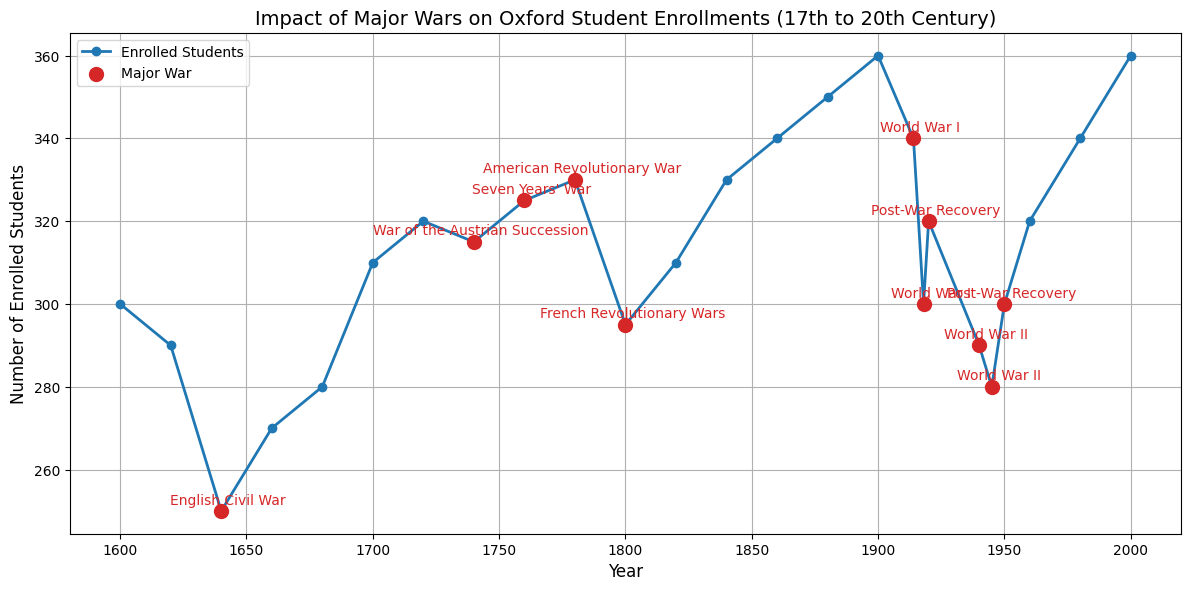What is the lowest student enrollment during a major war? To determine the lowest student enrollment during a major war, look for the points marked in red. The lowest value among these points is 280 students during World War II in 1945.
Answer: 280 Which major war resulted in the highest decrease in student enrollments? Check the differences in student enrollments before and during/after each major war. The most significant difference is observed during World War II, where enrollments dropped from 340 in 1914 to 300 in 1918, a decrease of 40 students.
Answer: World War II In which periods do we see a recovery in student enrollments after a major war, and by how much does the enrollment increase in these periods? After World War I, student enrollments increase from 300 in 1918 to 320 in 1920, an increase of 20 students. After World War II, enrollments rise from 280 in 1945 to 300 in 1950, an increase of 20 students.
Answer: Post-World War I: 20, Post-World War II: 20 What is the average student enrollment for the decade 1900-1910? Look at the enrollment numbers for the years 1900 (360). The average is calculated from (360) / 1 = 360.
Answer: 360 How does the student enrollment in 1740 (War of the Austrian Succession) compare to that in 1760 (Seven Years' War)? Compare the enrollment numbers for 1740 and 1760. In 1740, the enrollment was 315, while in 1760, it was 325. The enrollment in 1760 is higher by 10 students.
Answer: 1760 Which major war saw the least impact on student enrollment, considering the immediate pre- and post-war figures? Compare the pre- and post-war figures for each major war. The American Revolutionary War shows minimal impact, with enrollments changing slightly from 325 in 1760 to 330 in 1780.
Answer: American Revolutionary War What is the total decrease in student enrollment during World War I? Subtract the enrollment figures at the end of World War I (300 in 1918) from the figures at the start (340 in 1914). The total decrease is 40 students.
Answer: 40 How many major wars saw a decrease in student enrollment reaching or going below 300? Evaluate the enrollment figures for each major war. The English Civil War (250 in 1640), World War I (300 in 1918), and World War II (280 in 1945) saw enrollments go below or reach 300.
Answer: 3 